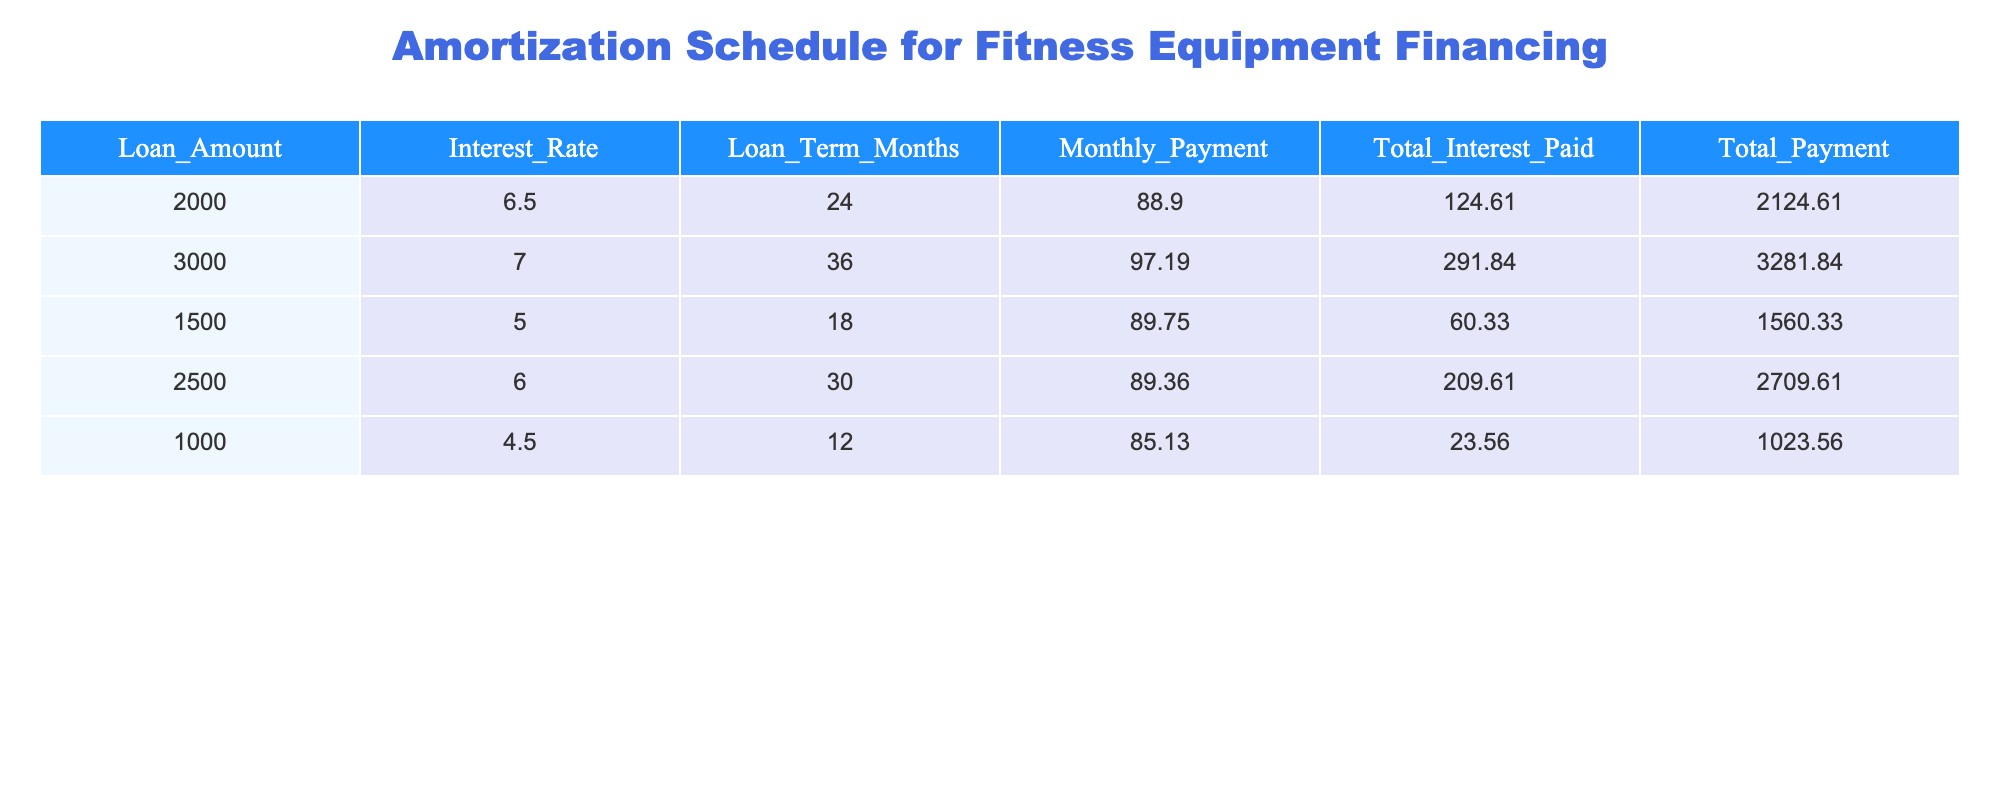What is the monthly payment for the $2000 loan? The monthly payment for the $2000 loan can be found directly in the table under the "Monthly_Payment" column for that specific loan amount. It is listed as 88.90.
Answer: 88.90 How much total interest will be paid for the $3000 loan? The total interest paid for the $3000 loan is found in the "Total_Interest_Paid" column corresponding to that loan. It is recorded as 291.84.
Answer: 291.84 Which loan term has the highest monthly payment? To find the highest monthly payment, we compare the "Monthly_Payment" values for each loan. The maximum value is 97.19 for the $3000 loan, which has a term of 36 months.
Answer: 36 months What is the total payment for the loan with the lowest interest rate? The loan with the lowest interest rate is the $1000 loan at 4.5%. The total payment for this loan is found in the "Total_Payment" column, which is 1023.56.
Answer: 1023.56 If you combine the total interest paid for the $2500 and $1500 loans, what is the sum? First, we find the total interest for both loans: for the $2500 loan, the total interest is 209.61, and for the $1500 loan, it is 60.33. Adding these together, we get 209.61 + 60.33 = 269.94.
Answer: 269.94 Does any loan have a total payment of over $2500? By checking the "Total_Payment" column, we see that the loans of $3000 (3281.84) and $2500 (2709.61) have total payments over $2500. Therefore, the answer is yes.
Answer: Yes What is the average monthly payment across all loans? To find the average monthly payment, we sum all the monthly payments (88.90 + 97.19 + 89.75 + 89.36 + 85.13 = 450.33) and divide by the number of loans (5), which gives us 450.33 / 5 = 90.066.
Answer: 90.07 Which loan has the highest total payment? By comparing the "Total_Payment" values, the $3000 loan has the highest total payment at 3281.84.
Answer: $3000 loan What is the median total interest paid among the loans? To find the median, we first list the total interest paid in ascending order: 23.56, 60.33, 124.61, 209.61, 291.84. The median is the middle value, which is 124.61 for the middle (3rd) loan.
Answer: 124.61 